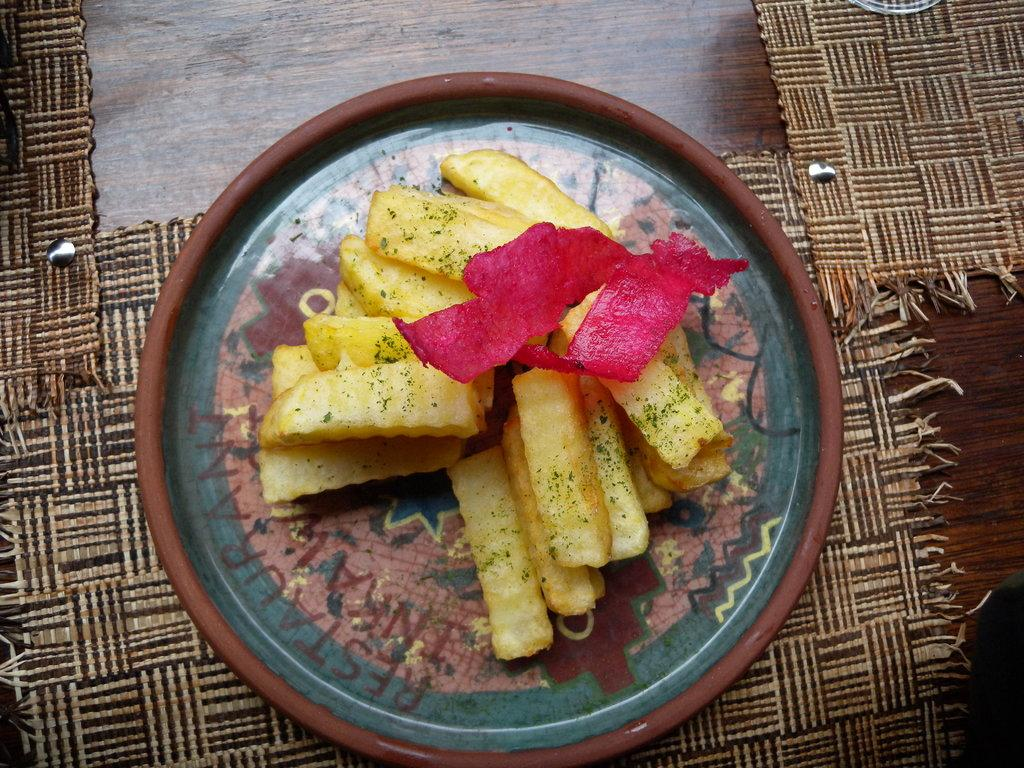What is on the plate in the image? There is food on a plate in the image. What can be observed about the plate itself? The plate has multiple colors. What colors are present in the food on the plate? The food has yellow and red colors. What is located beneath the plate in the image? There is a mat on the table in the image. What type of animal is depicted in the plot of the image? There is no plot or animal present in the image; it features a plate of food with multiple colors and a mat on the table. How much sugar is visible in the image? There is no sugar visible in the image; it only shows a plate of food with yellow and red colors, a multi-colored plate, and a mat on the table. 